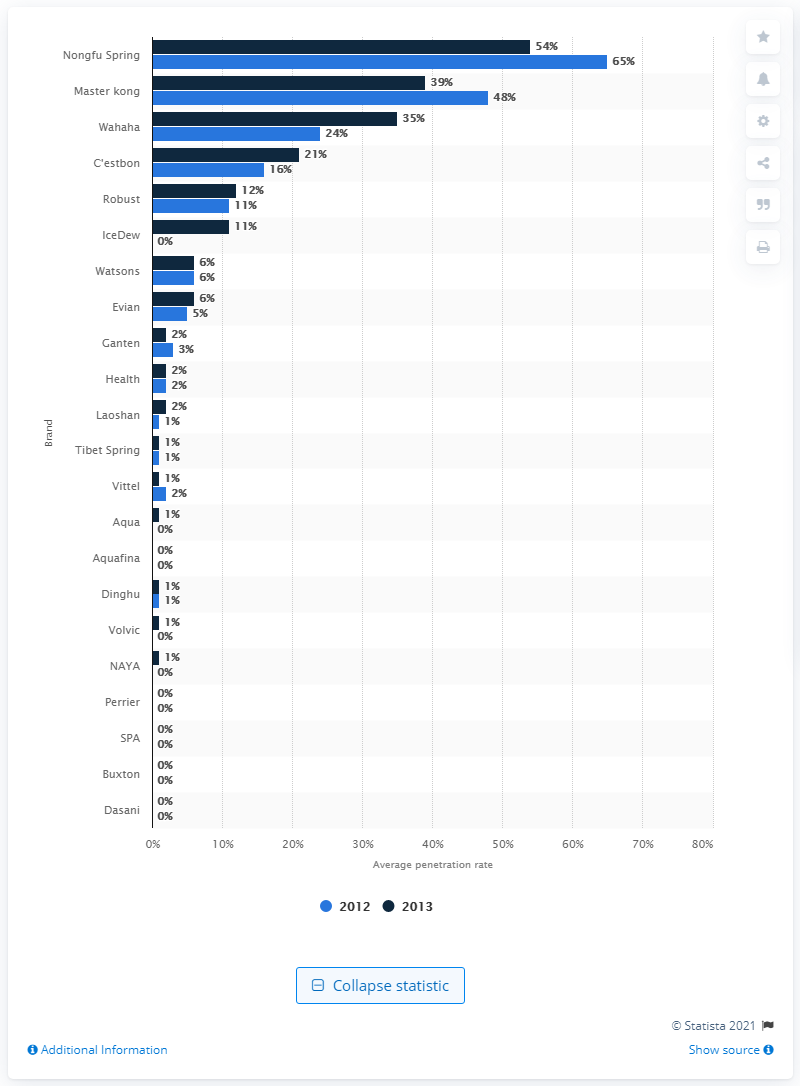Outline some significant characteristics in this image. In a survey conducted in 2013, 11% of respondents reported purchasing IceDew bottled water during the last three to twelve months. 